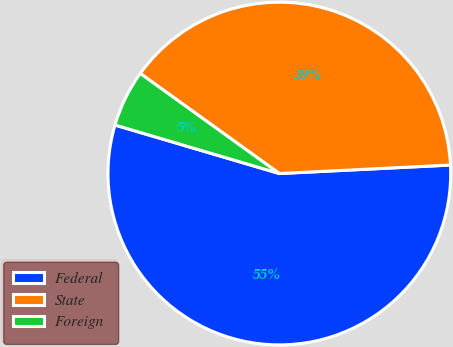Convert chart to OTSL. <chart><loc_0><loc_0><loc_500><loc_500><pie_chart><fcel>Federal<fcel>State<fcel>Foreign<nl><fcel>55.36%<fcel>39.29%<fcel>5.36%<nl></chart> 